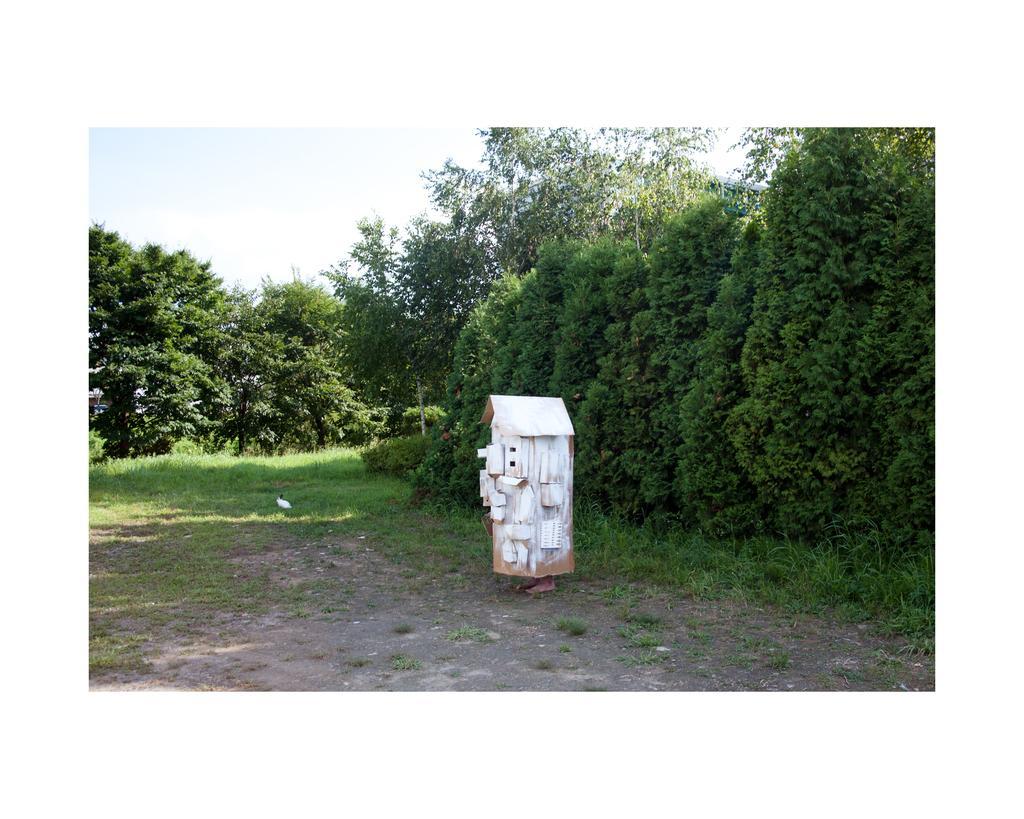Please provide a concise description of this image. I this picture I can see grass ground and and indifferent white color thing. There are number of trees. There is clouds in the sky 